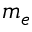<formula> <loc_0><loc_0><loc_500><loc_500>m _ { e }</formula> 